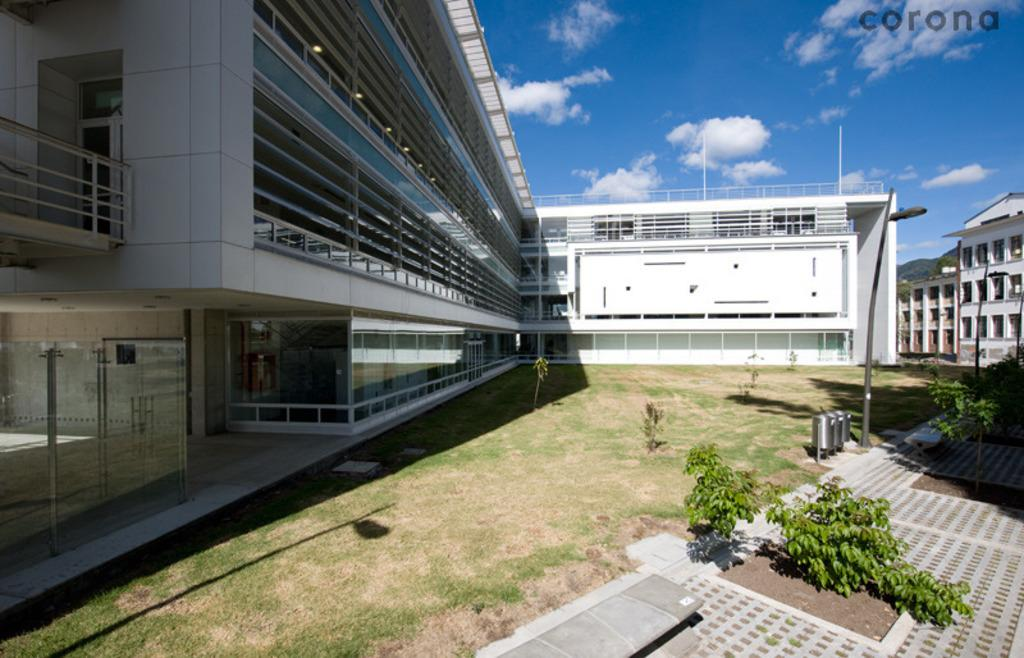What can be seen in the sky in the image? The sky with clouds is visible in the image. What type of structures are present in the image? There are buildings in the image. What are the poles used for in the image? Poles are present in the image, and some of them have street lights attached to them. What are the street poles supporting in the image? Street lights are visible in the image, attached to the street poles. What can be used for disposing of waste in the image? Bins are in the image for disposing of waste. What is visible on the ground in the image? The ground is visible in the image. What type of vegetation is present in the image? Plants are present in the image. How many cakes are balanced on the eye of the person in the image? There is no person or eye present in the image, and therefore no cakes can be balanced on an eye. 